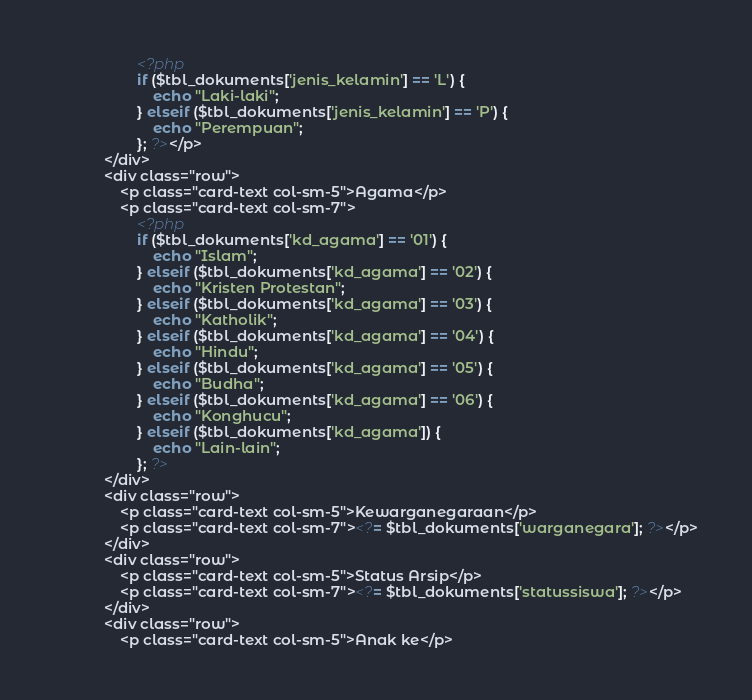<code> <loc_0><loc_0><loc_500><loc_500><_PHP_>                    <?php
                    if ($tbl_dokuments['jenis_kelamin'] == 'L') {
                        echo "Laki-laki";
                    } elseif ($tbl_dokuments['jenis_kelamin'] == 'P') {
                        echo "Perempuan";
                    }; ?></p>
            </div>
            <div class="row">
                <p class="card-text col-sm-5">Agama</p>
                <p class="card-text col-sm-7">
                    <?php
                    if ($tbl_dokuments['kd_agama'] == '01') {
                        echo "Islam";
                    } elseif ($tbl_dokuments['kd_agama'] == '02') {
                        echo "Kristen Protestan";
                    } elseif ($tbl_dokuments['kd_agama'] == '03') {
                        echo "Katholik";
                    } elseif ($tbl_dokuments['kd_agama'] == '04') {
                        echo "Hindu";
                    } elseif ($tbl_dokuments['kd_agama'] == '05') {
                        echo "Budha";
                    } elseif ($tbl_dokuments['kd_agama'] == '06') {
                        echo "Konghucu";
                    } elseif ($tbl_dokuments['kd_agama']) {
                        echo "Lain-lain";
                    }; ?>
            </div>
            <div class="row">
                <p class="card-text col-sm-5">Kewarganegaraan</p>
                <p class="card-text col-sm-7"><?= $tbl_dokuments['warganegara']; ?></p>
            </div>
            <div class="row">
                <p class="card-text col-sm-5">Status Arsip</p>
                <p class="card-text col-sm-7"><?= $tbl_dokuments['statussiswa']; ?></p>
            </div>
            <div class="row">
                <p class="card-text col-sm-5">Anak ke</p></code> 